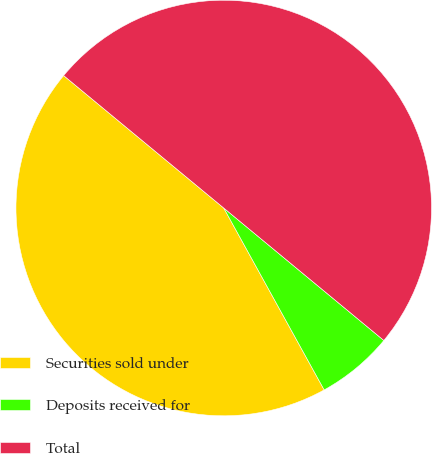<chart> <loc_0><loc_0><loc_500><loc_500><pie_chart><fcel>Securities sold under<fcel>Deposits received for<fcel>Total<nl><fcel>44.03%<fcel>5.97%<fcel>50.0%<nl></chart> 